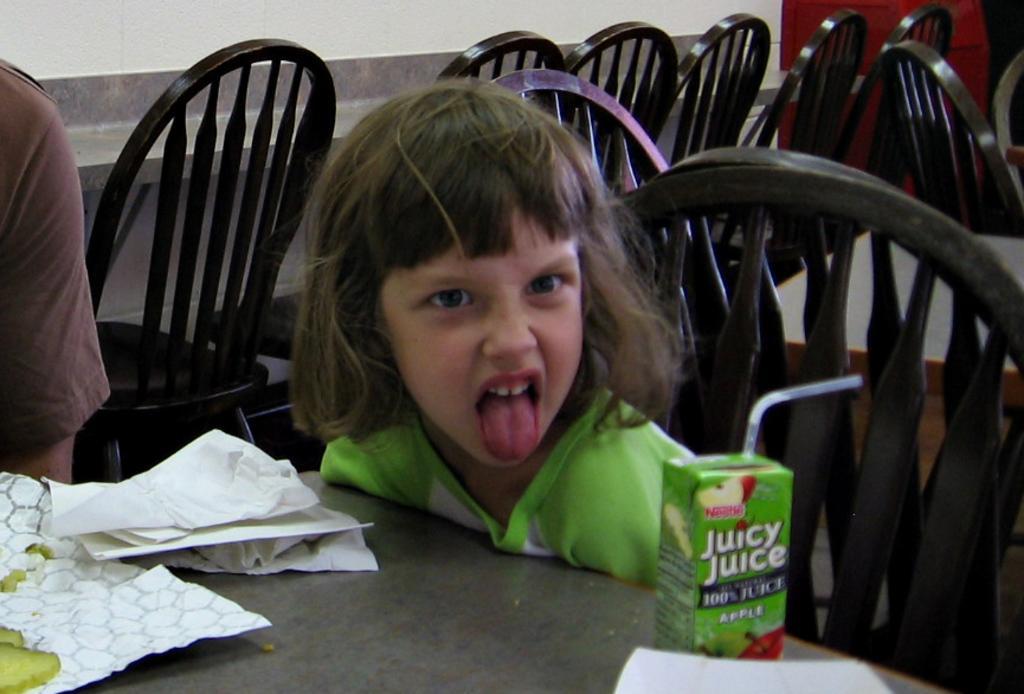In one or two sentences, can you explain what this image depicts? In this image there are two persons in the center the girl is sitting on the chair and is taking her tongue out of the mouth. In the front there is a juice bottle with a name juicy juice at the right side. On the left side there are papers kept on the table, on the left side i can see a hand of the person wearing a brown colour shirt. In the background there are some chairs and the table and wall red in colour and white in colour. 